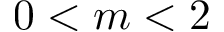<formula> <loc_0><loc_0><loc_500><loc_500>0 < m < 2</formula> 